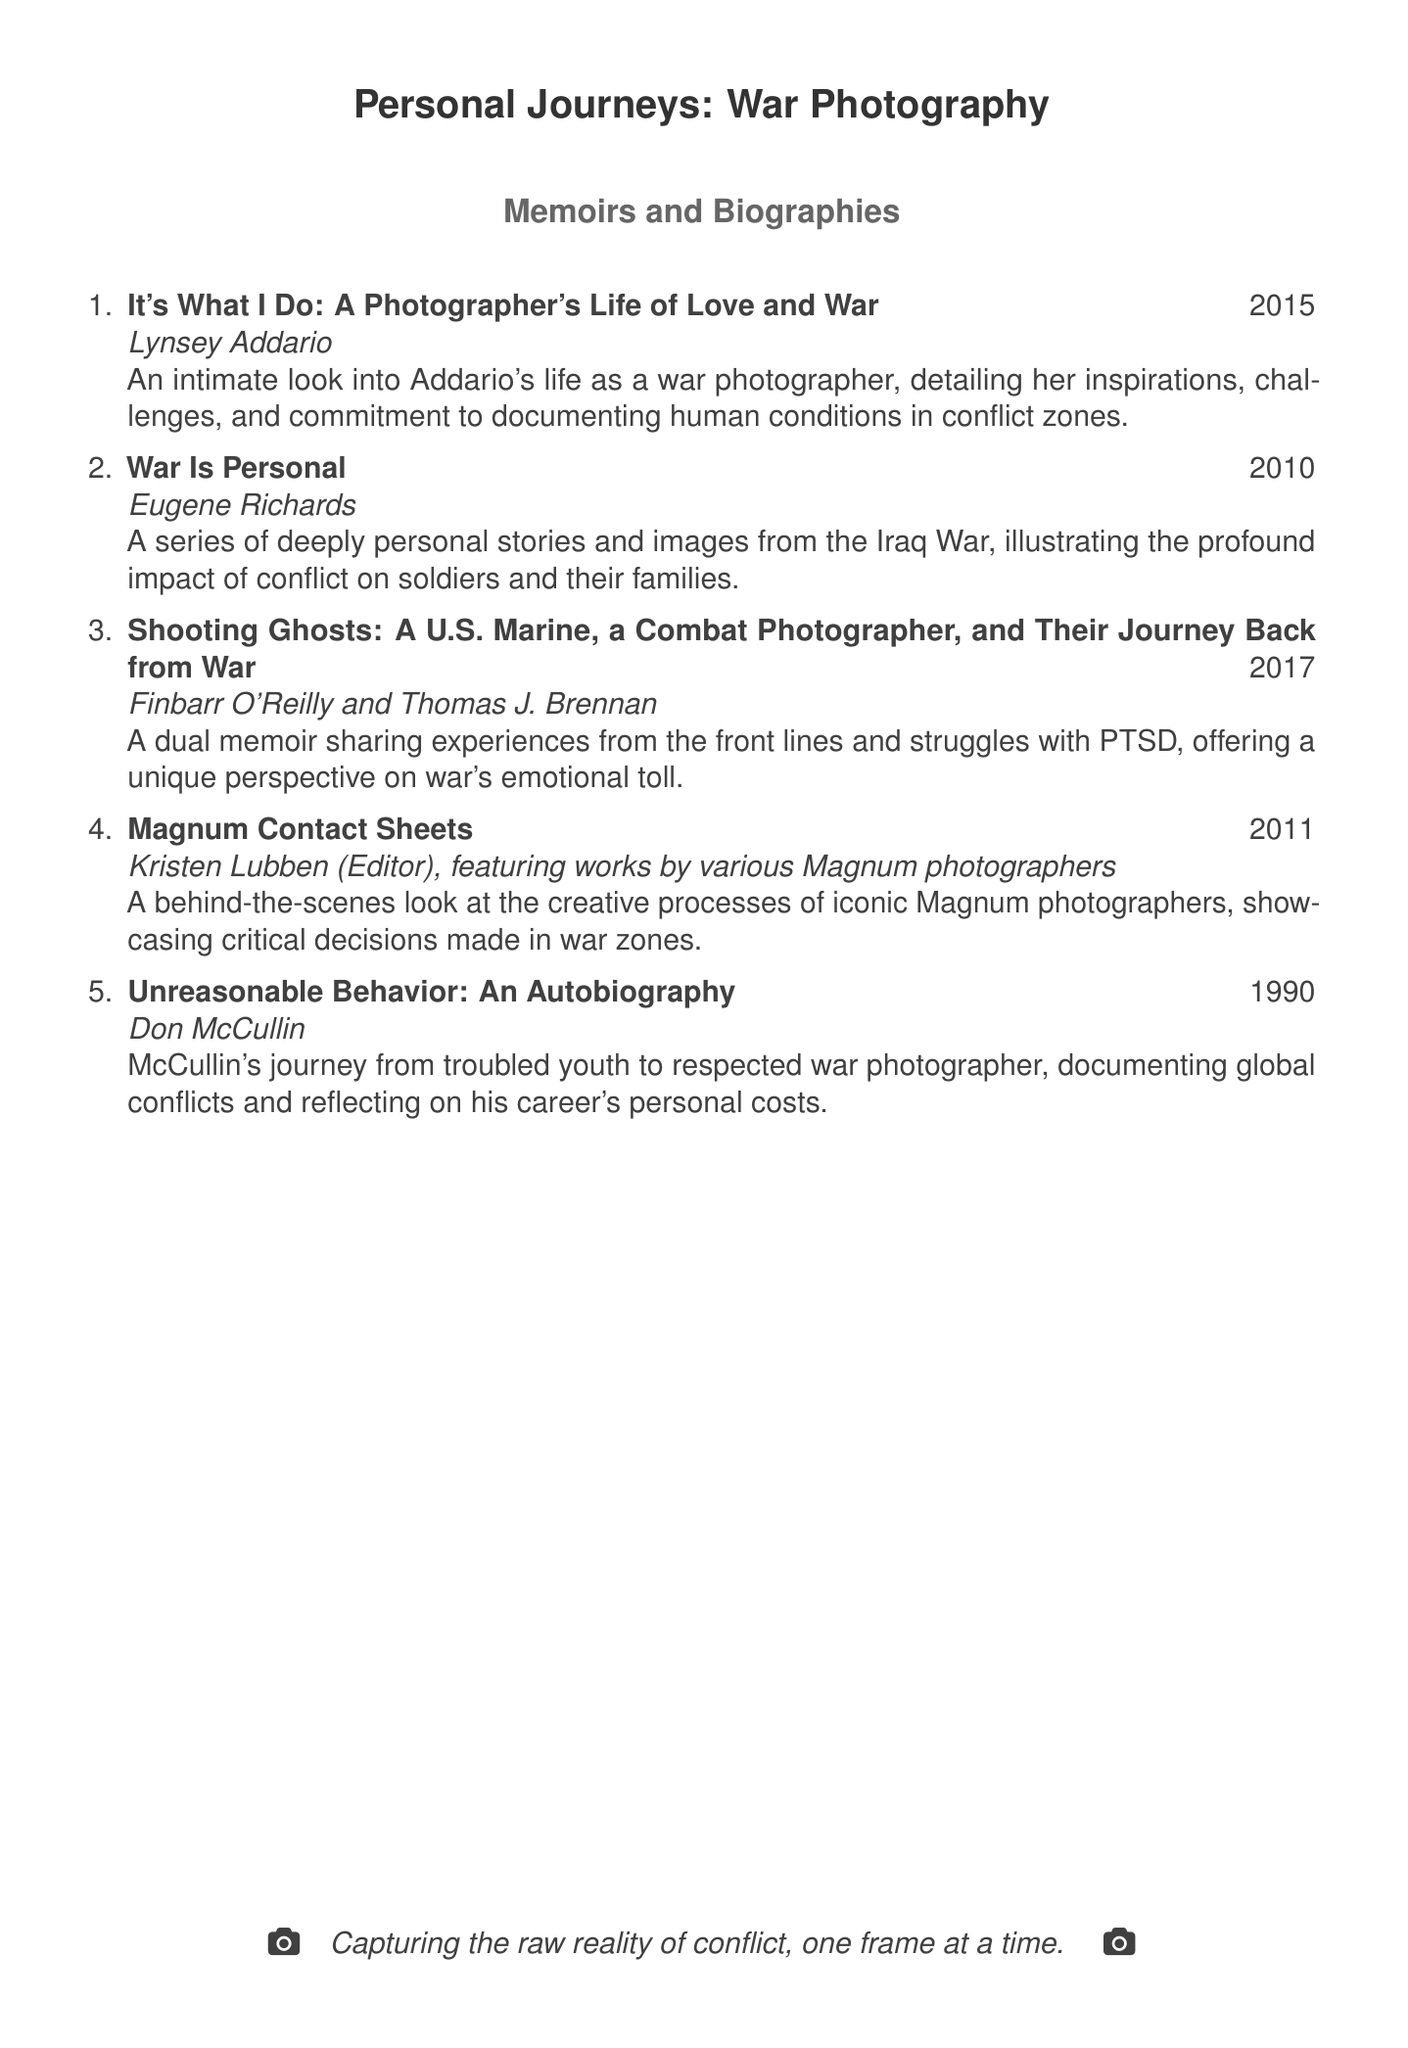What is the title of Lynsey Addario's memoir? The title of Lynsey Addario's memoir is found in the first entry of the list.
Answer: It's What I Do: A Photographer's Life of Love and War What year was "War Is Personal" published? The year of publication for "War Is Personal" is specified in the second entry of the list.
Answer: 2010 Who is the co-author of "Shooting Ghosts"? The co-author of "Shooting Ghosts," as indicated in the third entry, is mentioned.
Answer: Thomas J. Brennan How many memoirs are listed in the bibliography? The total number of memoirs can be counted by looking at the numbered list in the document.
Answer: 5 What is a significant theme in "Unreasonable Behavior" by Don McCullin? The theme is derived from the title and description provided in the last entry of the list.
Answer: Personal costs Who edited "Magnum Contact Sheets"? The editor of "Magnum Contact Sheets" is outlined in the fourth entry of the list.
Answer: Kristen Lubben What conflict is highlighted in Eugene Richards' memoir? The conflict mentioned in the second entry is identified in the document.
Answer: Iraq War Which memoir features critical decisions made in war zones? The memoir that discusses critical decisions is specified in the fourth entry.
Answer: Magnum Contact Sheets 